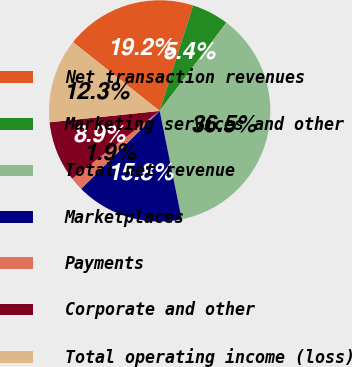Convert chart. <chart><loc_0><loc_0><loc_500><loc_500><pie_chart><fcel>Net transaction revenues<fcel>Marketing services and other<fcel>Total net revenue<fcel>Marketplaces<fcel>Payments<fcel>Corporate and other<fcel>Total operating income (loss)<nl><fcel>19.22%<fcel>5.4%<fcel>36.51%<fcel>15.77%<fcel>1.94%<fcel>8.85%<fcel>12.31%<nl></chart> 